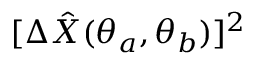Convert formula to latex. <formula><loc_0><loc_0><loc_500><loc_500>[ \Delta \hat { X } ( \theta _ { a } , \theta _ { b } ) ] ^ { 2 }</formula> 